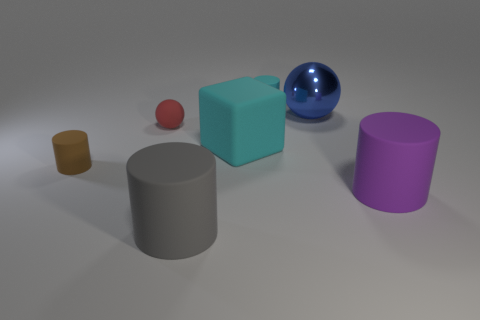Subtract all brown cylinders. How many cylinders are left? 3 Add 1 big cyan rubber cubes. How many objects exist? 8 Subtract all gray cylinders. How many cylinders are left? 3 Subtract all blocks. How many objects are left? 6 Add 5 cylinders. How many cylinders exist? 9 Subtract 0 blue cylinders. How many objects are left? 7 Subtract all blue spheres. Subtract all gray cubes. How many spheres are left? 1 Subtract all gray things. Subtract all balls. How many objects are left? 4 Add 6 red matte objects. How many red matte objects are left? 7 